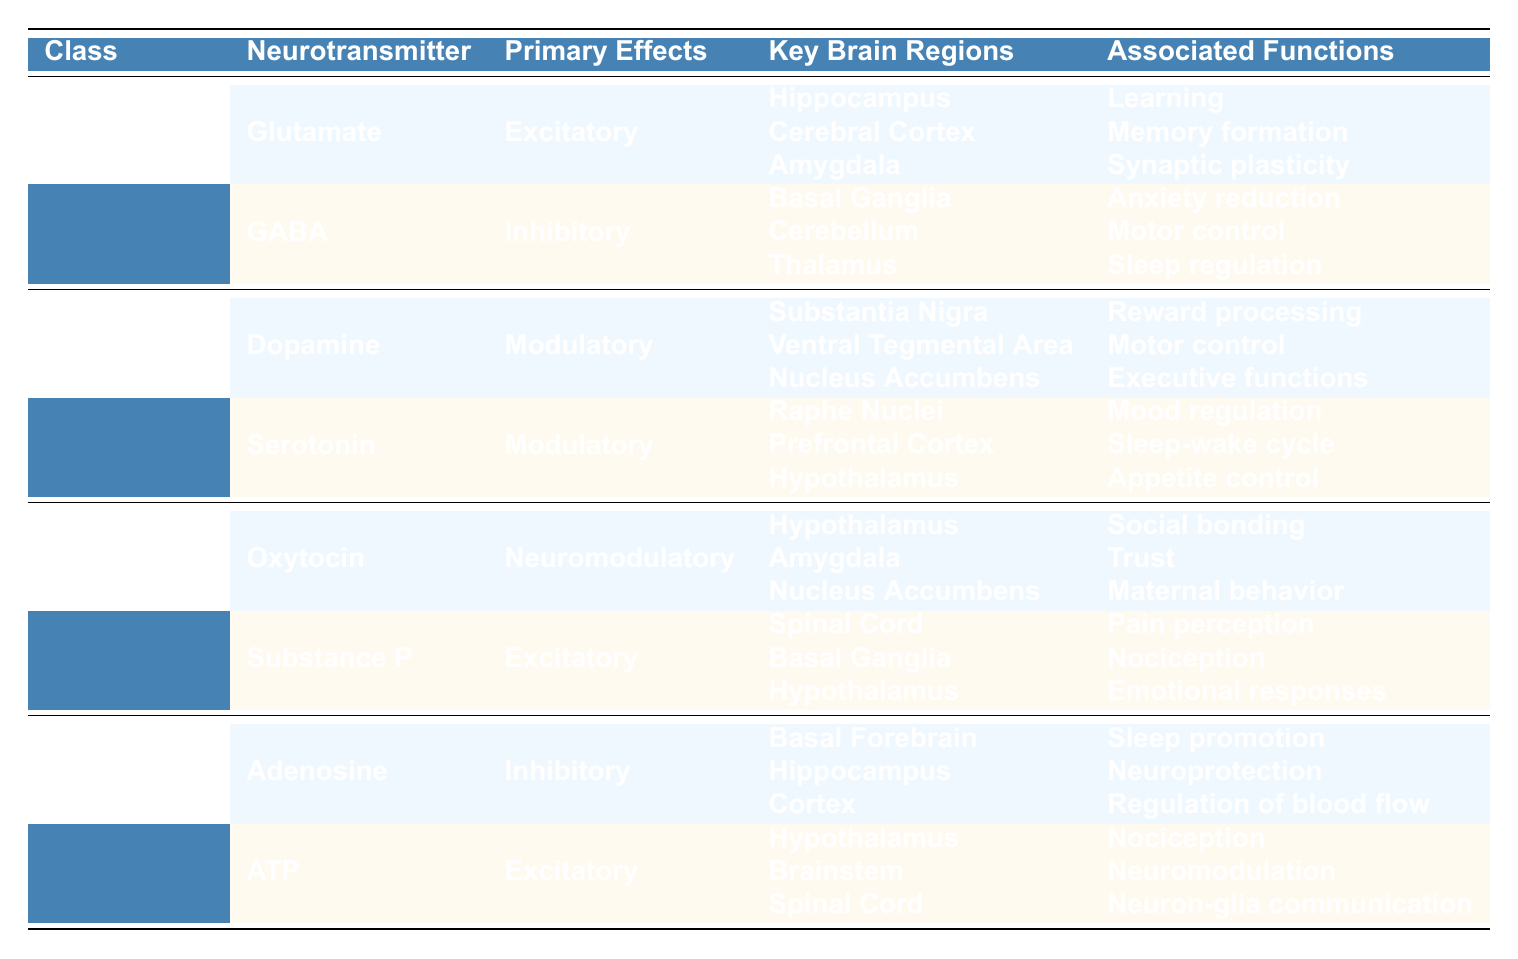What are the primary effects of GABA? The table indicates that GABA has primary effects categorized as "Inhibitory."
Answer: Inhibitory Which brain regions are associated with glutamate? The table lists "Hippocampus," "Cerebral Cortex," and "Amygdala" as the key brain regions associated with glutamate.
Answer: Hippocampus, Cerebral Cortex, Amygdala Do both dopamine and serotonin have similar primary effects? The table shows that both neurotransmitters are categorized as "Modulatory," indicating they share the same primary effect.
Answer: Yes How many neuropeptides are listed in the table? There are two neuropeptides mentioned in the Peptides class: "Oxytocin" and "Substance P." Thus, the total is 2.
Answer: 2 Which neurotransmitter is associated with pain perception? The table indicates that "Substance P" is associated with pain perception under its associated functions.
Answer: Substance P What is the common feature of monoamines regarding their primary effects? The primary effects listed for both dopamine and serotonin are "Modulatory," which is the common feature for the monoamines class.
Answer: Modulatory Which class of neurotransmitters has the most examples listed? The table shows that both the Amino Acids and Monoamines classes each have two examples, while Peptides and Purines also have two, hence none has more than two. The count is equal for these four classes.
Answer: None What functions are primarily associated with adenosine? According to the table, the associated functions of adenosine include "Sleep promotion," "Neuroprotection," and "Regulation of blood flow."
Answer: Sleep promotion, Neuroprotection, Regulation of blood flow Is GABA associated with the cerebellum? The table confirms that GABA is indeed associated with the cerebellum under its key brain regions.
Answer: Yes Which neurotransmitter class includes oxytocin? The table appropriates oxytocin to the Peptides class based on its grouping within the examples section.
Answer: Peptides How does the primary effect of ATP compare to that of adenosine? The table shows that ATP has "Excitatory" primary effects while adenosine has "Inhibitory" effects, indicating opposite effects between these two neurotransmitters.
Answer: Opposite effects 